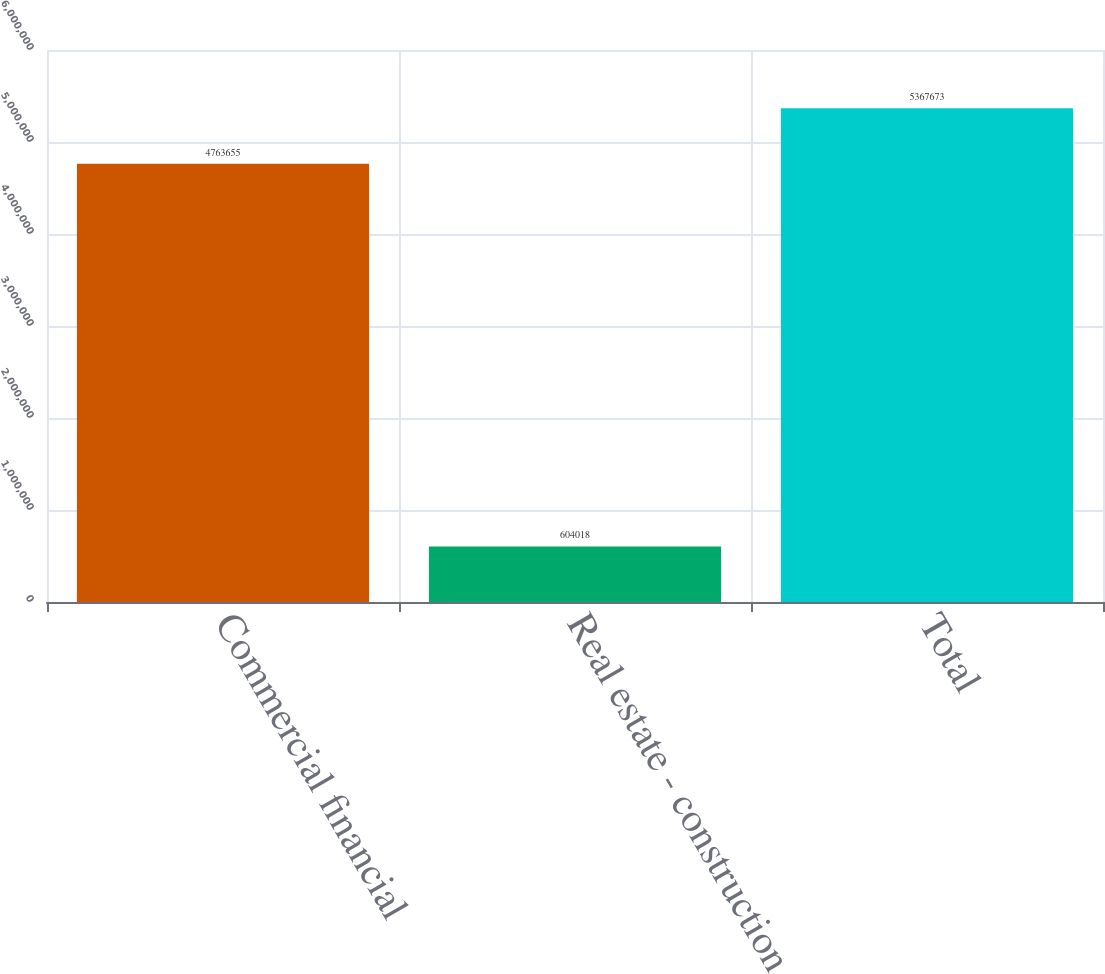Convert chart to OTSL. <chart><loc_0><loc_0><loc_500><loc_500><bar_chart><fcel>Commercial financial<fcel>Real estate - construction<fcel>Total<nl><fcel>4.76366e+06<fcel>604018<fcel>5.36767e+06<nl></chart> 